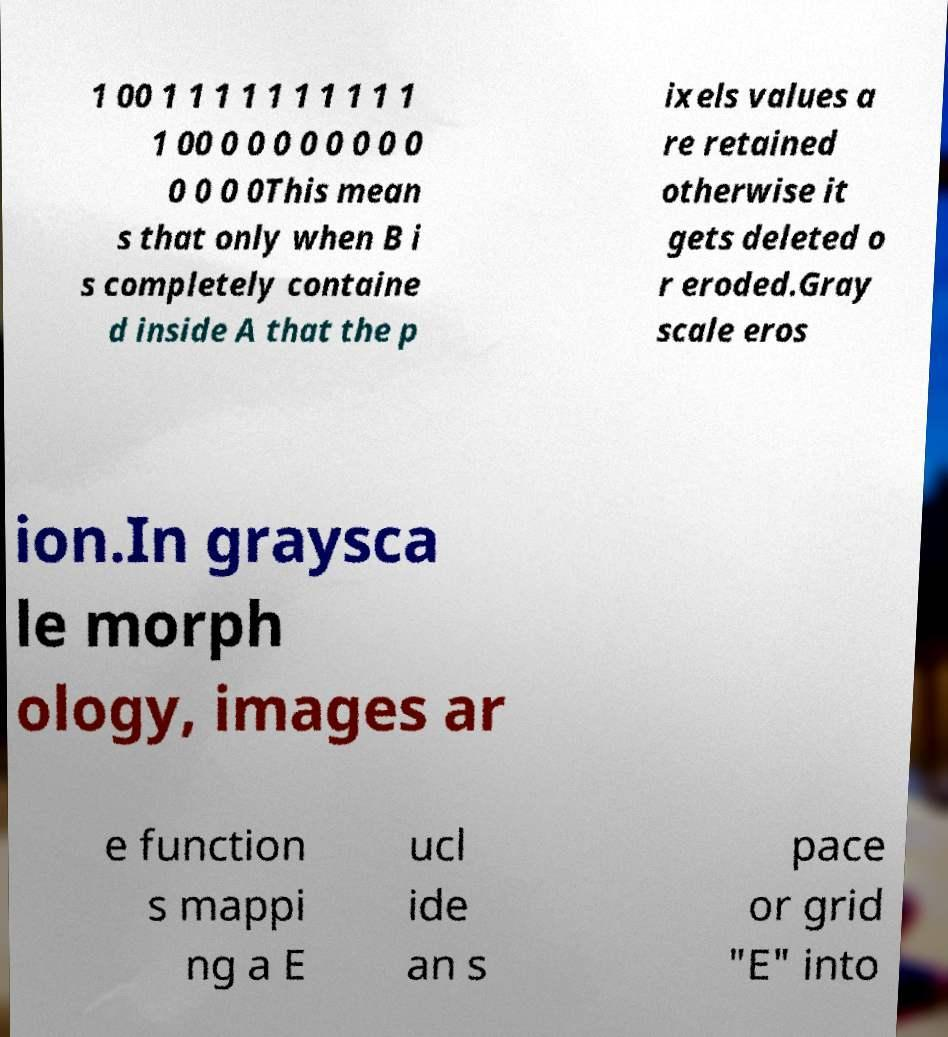For documentation purposes, I need the text within this image transcribed. Could you provide that? 1 00 1 1 1 1 1 1 1 1 1 1 1 00 0 0 0 0 0 0 0 0 0 0 0 0This mean s that only when B i s completely containe d inside A that the p ixels values a re retained otherwise it gets deleted o r eroded.Gray scale eros ion.In graysca le morph ology, images ar e function s mappi ng a E ucl ide an s pace or grid "E" into 